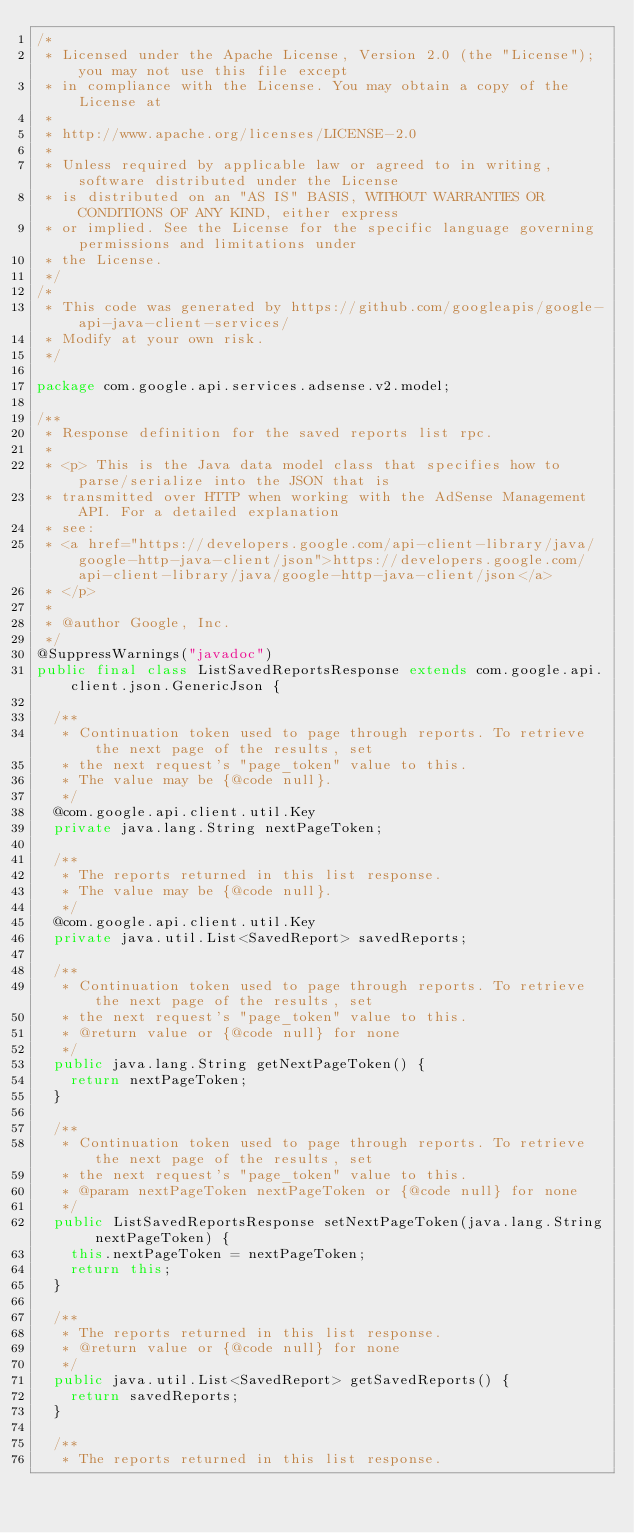Convert code to text. <code><loc_0><loc_0><loc_500><loc_500><_Java_>/*
 * Licensed under the Apache License, Version 2.0 (the "License"); you may not use this file except
 * in compliance with the License. You may obtain a copy of the License at
 *
 * http://www.apache.org/licenses/LICENSE-2.0
 *
 * Unless required by applicable law or agreed to in writing, software distributed under the License
 * is distributed on an "AS IS" BASIS, WITHOUT WARRANTIES OR CONDITIONS OF ANY KIND, either express
 * or implied. See the License for the specific language governing permissions and limitations under
 * the License.
 */
/*
 * This code was generated by https://github.com/googleapis/google-api-java-client-services/
 * Modify at your own risk.
 */

package com.google.api.services.adsense.v2.model;

/**
 * Response definition for the saved reports list rpc.
 *
 * <p> This is the Java data model class that specifies how to parse/serialize into the JSON that is
 * transmitted over HTTP when working with the AdSense Management API. For a detailed explanation
 * see:
 * <a href="https://developers.google.com/api-client-library/java/google-http-java-client/json">https://developers.google.com/api-client-library/java/google-http-java-client/json</a>
 * </p>
 *
 * @author Google, Inc.
 */
@SuppressWarnings("javadoc")
public final class ListSavedReportsResponse extends com.google.api.client.json.GenericJson {

  /**
   * Continuation token used to page through reports. To retrieve the next page of the results, set
   * the next request's "page_token" value to this.
   * The value may be {@code null}.
   */
  @com.google.api.client.util.Key
  private java.lang.String nextPageToken;

  /**
   * The reports returned in this list response.
   * The value may be {@code null}.
   */
  @com.google.api.client.util.Key
  private java.util.List<SavedReport> savedReports;

  /**
   * Continuation token used to page through reports. To retrieve the next page of the results, set
   * the next request's "page_token" value to this.
   * @return value or {@code null} for none
   */
  public java.lang.String getNextPageToken() {
    return nextPageToken;
  }

  /**
   * Continuation token used to page through reports. To retrieve the next page of the results, set
   * the next request's "page_token" value to this.
   * @param nextPageToken nextPageToken or {@code null} for none
   */
  public ListSavedReportsResponse setNextPageToken(java.lang.String nextPageToken) {
    this.nextPageToken = nextPageToken;
    return this;
  }

  /**
   * The reports returned in this list response.
   * @return value or {@code null} for none
   */
  public java.util.List<SavedReport> getSavedReports() {
    return savedReports;
  }

  /**
   * The reports returned in this list response.</code> 